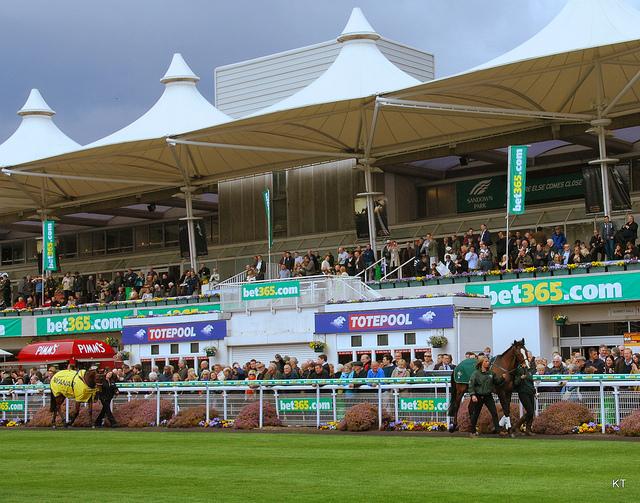How many horses are there?
Quick response, please. 2. What color is the grass?
Quick response, please. Green. What website is shown on the green signs?
Write a very short answer. Bet365com. 